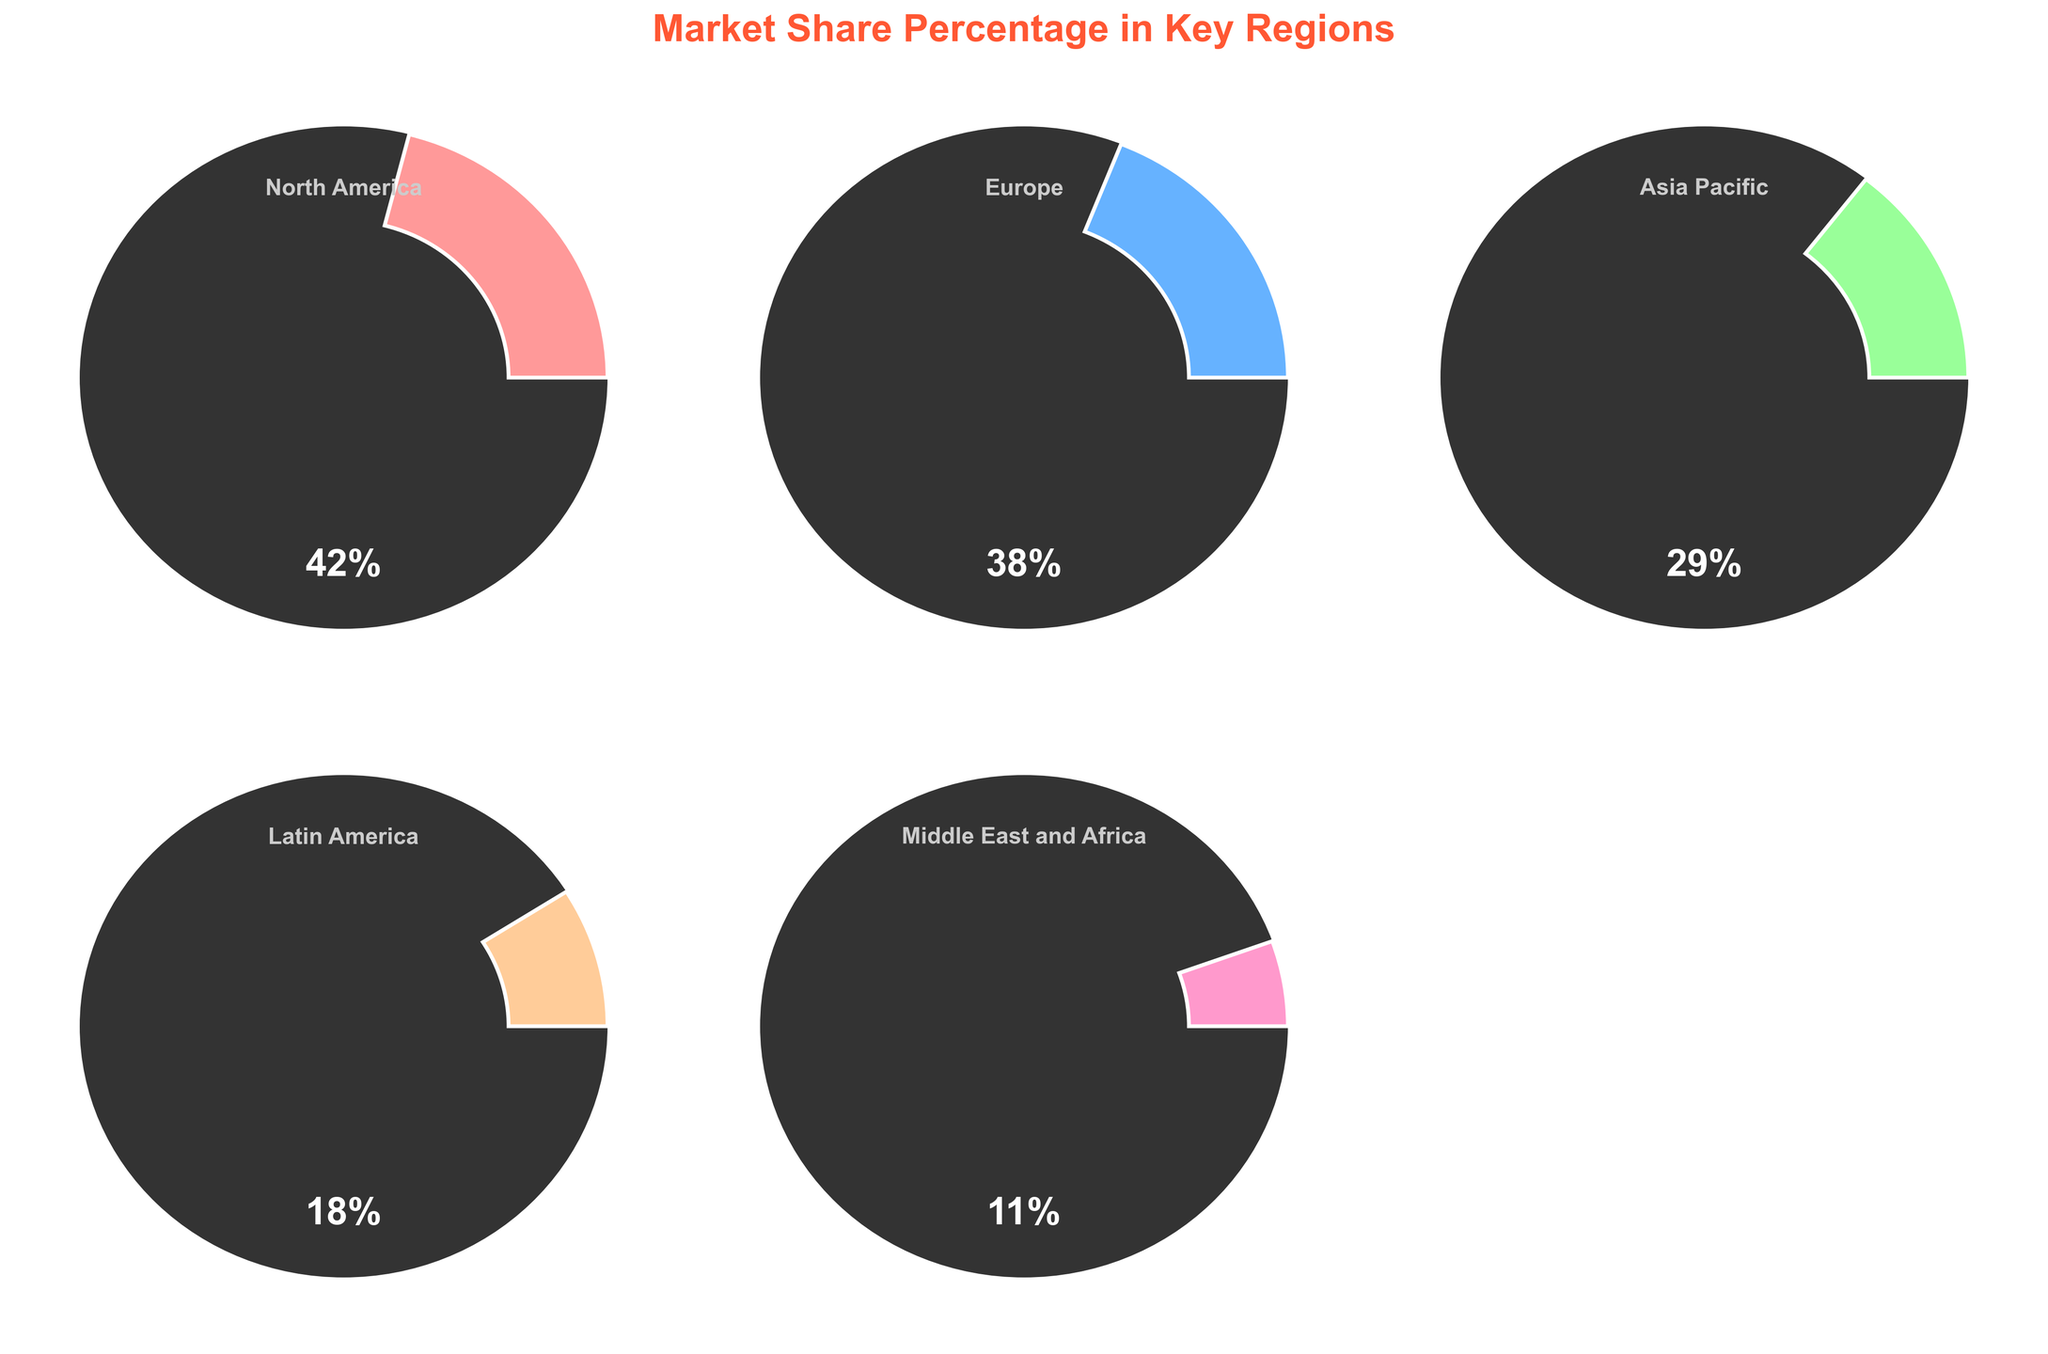Which region has the highest market share? By visually inspecting all the gauge charts, the North America gauge reaches the highest percentage, 42%.
Answer: North America What's the market share percentage of Europe? By looking at the gauge chart for Europe, the market share percentage is shown as 38%.
Answer: 38% How many regions are represented in the figure? By counting the number of gauge charts included in the figure, there are 5 regions represented.
Answer: 5 What is the combined market share percentage of Latin America and the Middle East and Africa? Add the market share percentages of Latin America (18%) and the Middle East and Africa (11%), resulting in 18% + 11% = 29%.
Answer: 29% Which region has the smallest market share? By inspecting all the gauge charts, the Middle East and Africa have the smallest market share at 11%.
Answer: Middle East and Africa What is the difference in market share between North America and Asia Pacific? Subtract the market share of Asia Pacific (29%) from the market share of North America (42%), resulting in 42% - 29% = 13%.
Answer: 13% Is Europe’s market share greater than Asia Pacific’s market share? Comparing the two market shares, Europe (38%) is greater than Asia Pacific's (29%).
Answer: Yes Which regions have a market share that is below 20%? By looking at the gauge charts, Latin America (18%) and the Middle East and Africa (11%) both have market shares below 20%.
Answer: Latin America, Middle East and Africa What's the range of market shares represented in the figure? The range is calculated by subtracting the smallest market share (Middle East and Africa at 11%) from the largest market share (North America at 42%), resulting in 42% - 11% = 31%.
Answer: 31% 